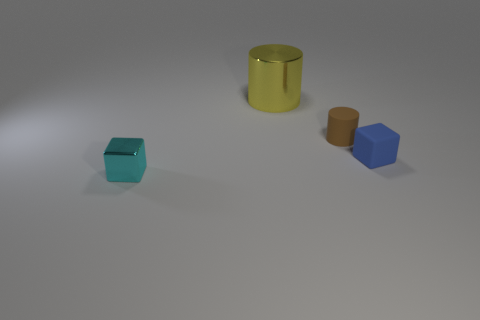What number of other objects are the same shape as the tiny cyan object?
Your response must be concise. 1. What is the color of the other block that is the same size as the blue rubber block?
Make the answer very short. Cyan. How many blocks are either big yellow objects or tiny things?
Offer a terse response. 2. What number of blue metal cylinders are there?
Make the answer very short. 0. Do the big yellow object and the tiny thing behind the blue rubber thing have the same shape?
Ensure brevity in your answer.  Yes. How many objects are either matte spheres or shiny things?
Provide a short and direct response. 2. What is the shape of the matte thing to the left of the block that is right of the big yellow shiny object?
Offer a very short reply. Cylinder. Does the object to the right of the tiny cylinder have the same shape as the small brown object?
Your answer should be compact. No. There is a yellow cylinder that is made of the same material as the cyan cube; what size is it?
Your response must be concise. Large. How many objects are small cubes that are right of the big yellow metal thing or shiny objects that are behind the small metallic thing?
Your answer should be very brief. 2. 